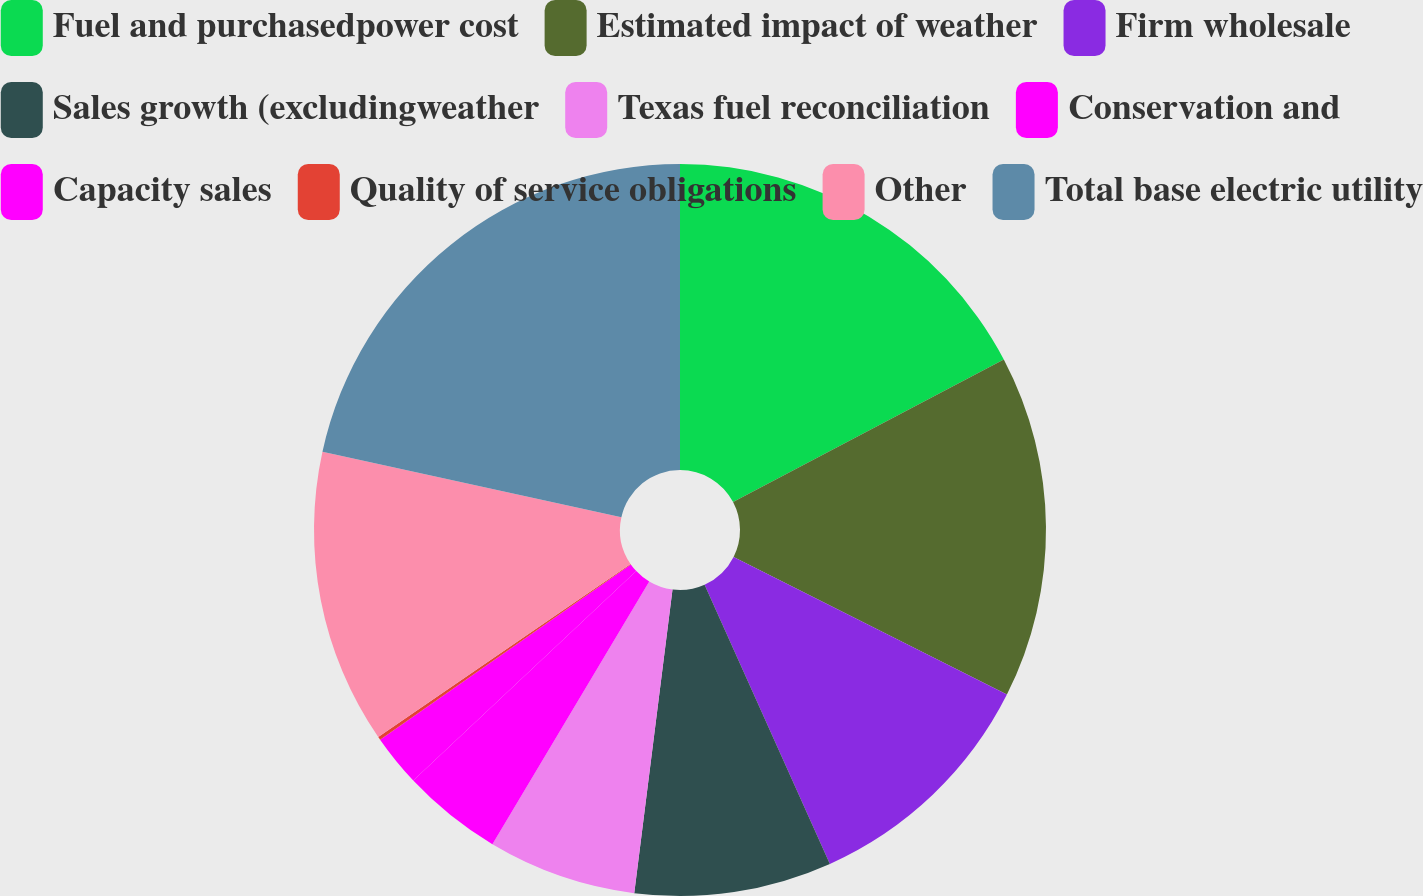Convert chart. <chart><loc_0><loc_0><loc_500><loc_500><pie_chart><fcel>Fuel and purchasedpower cost<fcel>Estimated impact of weather<fcel>Firm wholesale<fcel>Sales growth (excludingweather<fcel>Texas fuel reconciliation<fcel>Conservation and<fcel>Capacity sales<fcel>Quality of service obligations<fcel>Other<fcel>Total base electric utility<nl><fcel>17.28%<fcel>15.14%<fcel>10.86%<fcel>8.71%<fcel>6.57%<fcel>4.43%<fcel>2.29%<fcel>0.14%<fcel>13.0%<fcel>21.57%<nl></chart> 